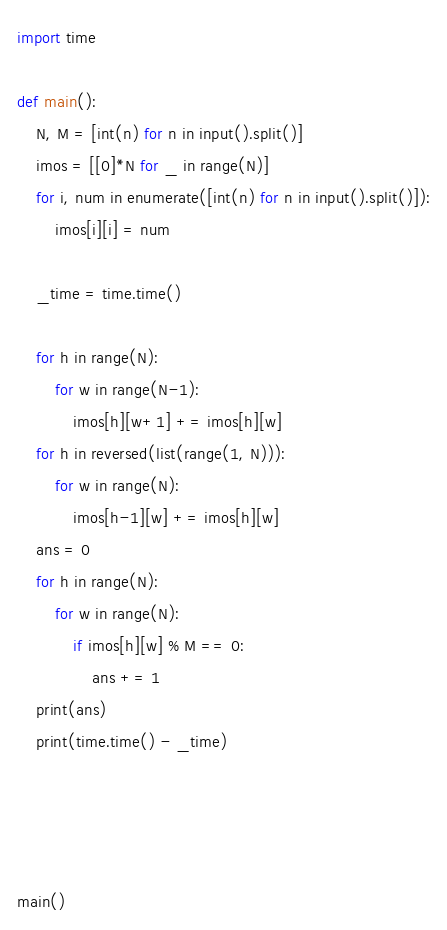Convert code to text. <code><loc_0><loc_0><loc_500><loc_500><_Python_>import time

def main():
    N, M = [int(n) for n in input().split()]
    imos = [[0]*N for _ in range(N)]
    for i, num in enumerate([int(n) for n in input().split()]):
        imos[i][i] = num
    
    _time = time.time()

    for h in range(N):
        for w in range(N-1):
            imos[h][w+1] += imos[h][w]
    for h in reversed(list(range(1, N))):
        for w in range(N):
            imos[h-1][w] += imos[h][w]
    ans = 0
    for h in range(N):
        for w in range(N):
            if imos[h][w] % M == 0:
                ans += 1
    print(ans)
    print(time.time() - _time)

    


main()
</code> 